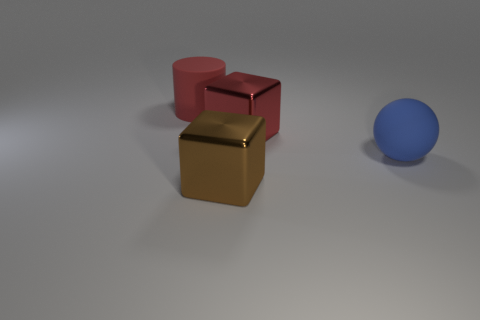Add 2 red cylinders. How many objects exist? 6 Subtract all balls. How many objects are left? 3 Subtract 0 cyan cubes. How many objects are left? 4 Subtract all small gray objects. Subtract all blue matte balls. How many objects are left? 3 Add 4 blue things. How many blue things are left? 5 Add 4 matte things. How many matte things exist? 6 